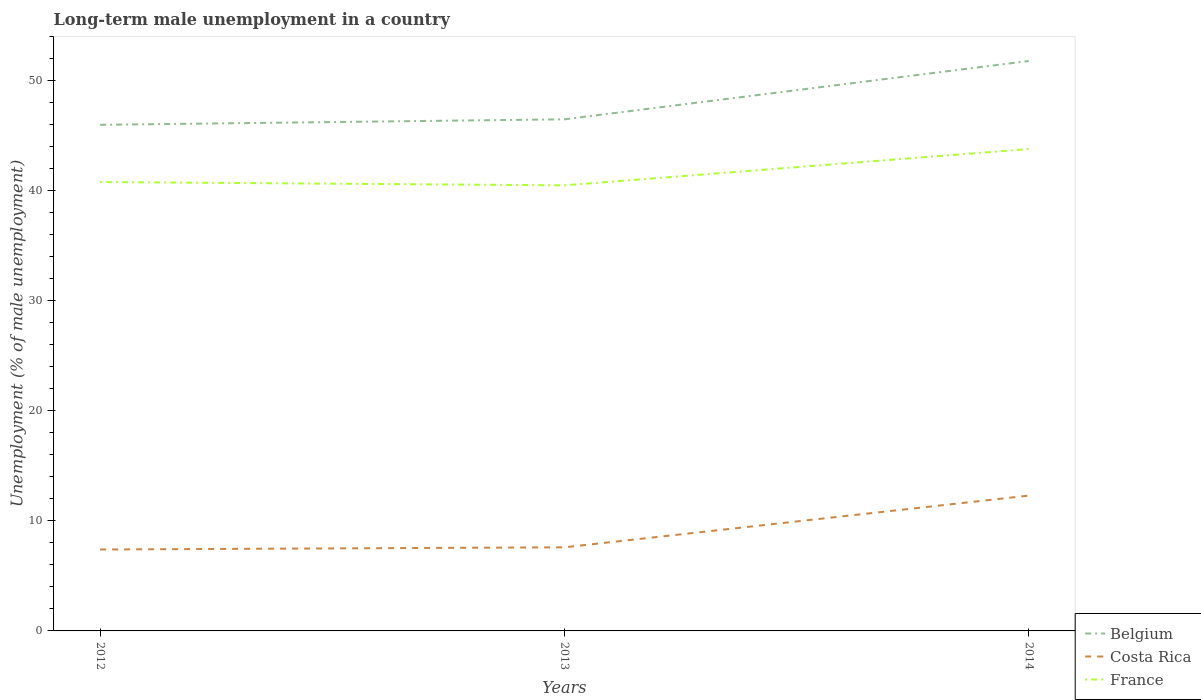How many different coloured lines are there?
Your answer should be compact. 3. Is the number of lines equal to the number of legend labels?
Offer a very short reply. Yes. Across all years, what is the maximum percentage of long-term unemployed male population in Costa Rica?
Give a very brief answer. 7.4. What is the total percentage of long-term unemployed male population in Costa Rica in the graph?
Ensure brevity in your answer.  -4.9. What is the difference between the highest and the second highest percentage of long-term unemployed male population in France?
Ensure brevity in your answer.  3.3. What is the difference between the highest and the lowest percentage of long-term unemployed male population in Belgium?
Your answer should be compact. 1. Is the percentage of long-term unemployed male population in Belgium strictly greater than the percentage of long-term unemployed male population in Costa Rica over the years?
Ensure brevity in your answer.  No. How many lines are there?
Keep it short and to the point. 3. How many years are there in the graph?
Provide a succinct answer. 3. Are the values on the major ticks of Y-axis written in scientific E-notation?
Make the answer very short. No. Does the graph contain any zero values?
Provide a succinct answer. No. How are the legend labels stacked?
Offer a very short reply. Vertical. What is the title of the graph?
Your answer should be very brief. Long-term male unemployment in a country. What is the label or title of the Y-axis?
Provide a short and direct response. Unemployment (% of male unemployment). What is the Unemployment (% of male unemployment) in Costa Rica in 2012?
Keep it short and to the point. 7.4. What is the Unemployment (% of male unemployment) of France in 2012?
Your answer should be very brief. 40.8. What is the Unemployment (% of male unemployment) in Belgium in 2013?
Your answer should be compact. 46.5. What is the Unemployment (% of male unemployment) in Costa Rica in 2013?
Offer a very short reply. 7.6. What is the Unemployment (% of male unemployment) of France in 2013?
Provide a succinct answer. 40.5. What is the Unemployment (% of male unemployment) of Belgium in 2014?
Your answer should be compact. 51.8. What is the Unemployment (% of male unemployment) in Costa Rica in 2014?
Your answer should be very brief. 12.3. What is the Unemployment (% of male unemployment) of France in 2014?
Ensure brevity in your answer.  43.8. Across all years, what is the maximum Unemployment (% of male unemployment) in Belgium?
Your answer should be very brief. 51.8. Across all years, what is the maximum Unemployment (% of male unemployment) in Costa Rica?
Keep it short and to the point. 12.3. Across all years, what is the maximum Unemployment (% of male unemployment) in France?
Give a very brief answer. 43.8. Across all years, what is the minimum Unemployment (% of male unemployment) of Belgium?
Make the answer very short. 46. Across all years, what is the minimum Unemployment (% of male unemployment) in Costa Rica?
Your answer should be compact. 7.4. Across all years, what is the minimum Unemployment (% of male unemployment) of France?
Give a very brief answer. 40.5. What is the total Unemployment (% of male unemployment) of Belgium in the graph?
Ensure brevity in your answer.  144.3. What is the total Unemployment (% of male unemployment) in Costa Rica in the graph?
Ensure brevity in your answer.  27.3. What is the total Unemployment (% of male unemployment) of France in the graph?
Your answer should be very brief. 125.1. What is the difference between the Unemployment (% of male unemployment) in Costa Rica in 2012 and that in 2014?
Make the answer very short. -4.9. What is the difference between the Unemployment (% of male unemployment) in France in 2012 and that in 2014?
Your answer should be compact. -3. What is the difference between the Unemployment (% of male unemployment) in Belgium in 2013 and that in 2014?
Keep it short and to the point. -5.3. What is the difference between the Unemployment (% of male unemployment) of Belgium in 2012 and the Unemployment (% of male unemployment) of Costa Rica in 2013?
Make the answer very short. 38.4. What is the difference between the Unemployment (% of male unemployment) of Belgium in 2012 and the Unemployment (% of male unemployment) of France in 2013?
Keep it short and to the point. 5.5. What is the difference between the Unemployment (% of male unemployment) in Costa Rica in 2012 and the Unemployment (% of male unemployment) in France in 2013?
Your answer should be very brief. -33.1. What is the difference between the Unemployment (% of male unemployment) of Belgium in 2012 and the Unemployment (% of male unemployment) of Costa Rica in 2014?
Your answer should be compact. 33.7. What is the difference between the Unemployment (% of male unemployment) in Costa Rica in 2012 and the Unemployment (% of male unemployment) in France in 2014?
Ensure brevity in your answer.  -36.4. What is the difference between the Unemployment (% of male unemployment) in Belgium in 2013 and the Unemployment (% of male unemployment) in Costa Rica in 2014?
Your answer should be compact. 34.2. What is the difference between the Unemployment (% of male unemployment) of Belgium in 2013 and the Unemployment (% of male unemployment) of France in 2014?
Provide a succinct answer. 2.7. What is the difference between the Unemployment (% of male unemployment) in Costa Rica in 2013 and the Unemployment (% of male unemployment) in France in 2014?
Ensure brevity in your answer.  -36.2. What is the average Unemployment (% of male unemployment) in Belgium per year?
Provide a succinct answer. 48.1. What is the average Unemployment (% of male unemployment) of Costa Rica per year?
Your response must be concise. 9.1. What is the average Unemployment (% of male unemployment) of France per year?
Ensure brevity in your answer.  41.7. In the year 2012, what is the difference between the Unemployment (% of male unemployment) in Belgium and Unemployment (% of male unemployment) in Costa Rica?
Make the answer very short. 38.6. In the year 2012, what is the difference between the Unemployment (% of male unemployment) of Costa Rica and Unemployment (% of male unemployment) of France?
Your response must be concise. -33.4. In the year 2013, what is the difference between the Unemployment (% of male unemployment) of Belgium and Unemployment (% of male unemployment) of Costa Rica?
Provide a short and direct response. 38.9. In the year 2013, what is the difference between the Unemployment (% of male unemployment) in Costa Rica and Unemployment (% of male unemployment) in France?
Make the answer very short. -32.9. In the year 2014, what is the difference between the Unemployment (% of male unemployment) in Belgium and Unemployment (% of male unemployment) in Costa Rica?
Ensure brevity in your answer.  39.5. In the year 2014, what is the difference between the Unemployment (% of male unemployment) in Belgium and Unemployment (% of male unemployment) in France?
Your response must be concise. 8. In the year 2014, what is the difference between the Unemployment (% of male unemployment) of Costa Rica and Unemployment (% of male unemployment) of France?
Make the answer very short. -31.5. What is the ratio of the Unemployment (% of male unemployment) in Costa Rica in 2012 to that in 2013?
Provide a succinct answer. 0.97. What is the ratio of the Unemployment (% of male unemployment) of France in 2012 to that in 2013?
Ensure brevity in your answer.  1.01. What is the ratio of the Unemployment (% of male unemployment) of Belgium in 2012 to that in 2014?
Your answer should be very brief. 0.89. What is the ratio of the Unemployment (% of male unemployment) of Costa Rica in 2012 to that in 2014?
Your response must be concise. 0.6. What is the ratio of the Unemployment (% of male unemployment) in France in 2012 to that in 2014?
Your answer should be compact. 0.93. What is the ratio of the Unemployment (% of male unemployment) of Belgium in 2013 to that in 2014?
Ensure brevity in your answer.  0.9. What is the ratio of the Unemployment (% of male unemployment) of Costa Rica in 2013 to that in 2014?
Ensure brevity in your answer.  0.62. What is the ratio of the Unemployment (% of male unemployment) of France in 2013 to that in 2014?
Your response must be concise. 0.92. What is the difference between the highest and the lowest Unemployment (% of male unemployment) of Belgium?
Your answer should be very brief. 5.8. What is the difference between the highest and the lowest Unemployment (% of male unemployment) in Costa Rica?
Offer a terse response. 4.9. 